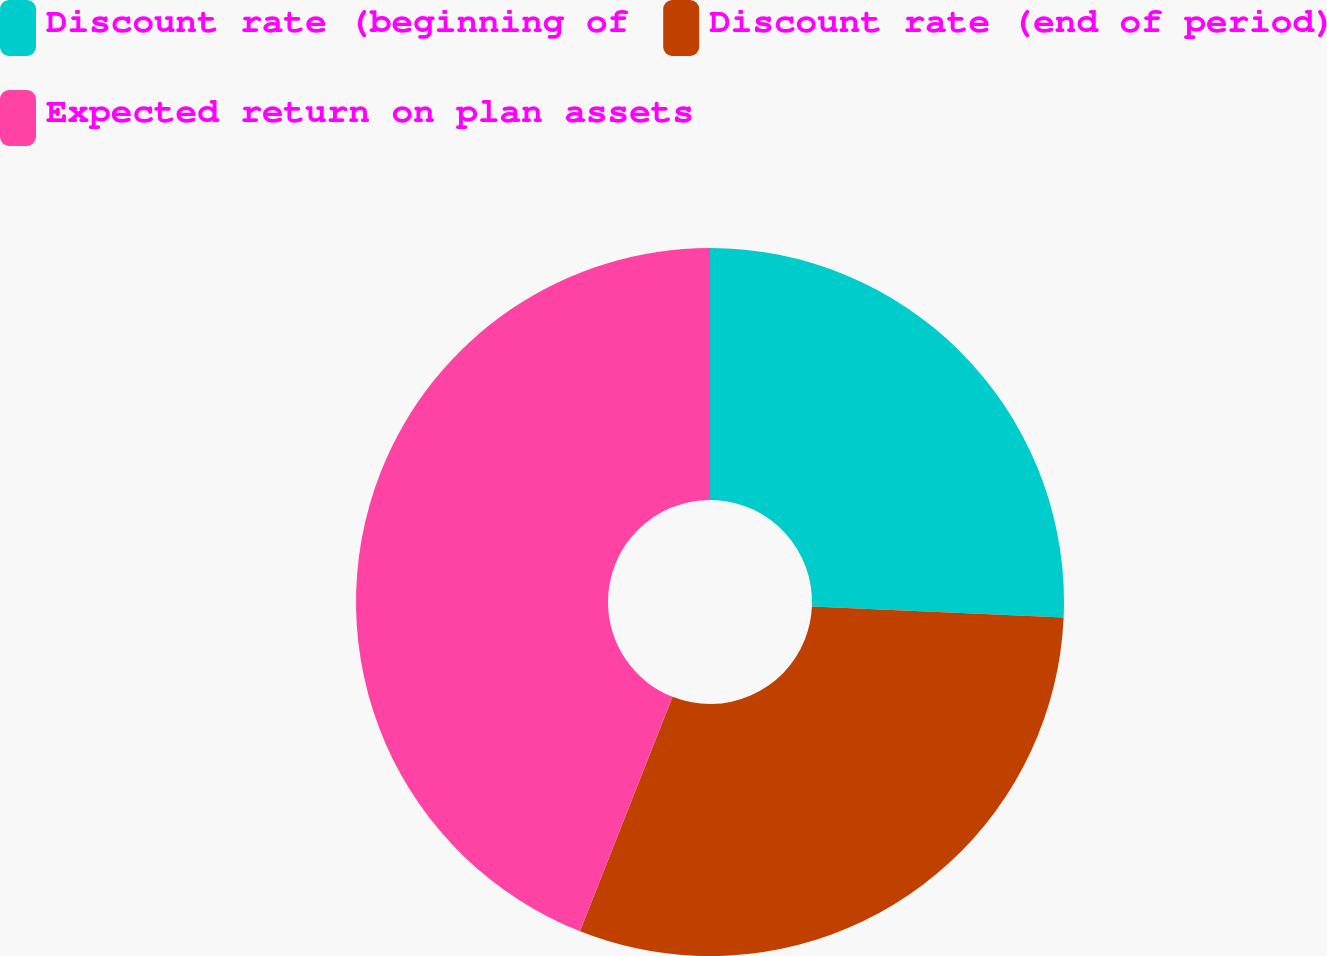Convert chart to OTSL. <chart><loc_0><loc_0><loc_500><loc_500><pie_chart><fcel>Discount rate (beginning of<fcel>Discount rate (end of period)<fcel>Expected return on plan assets<nl><fcel>25.7%<fcel>30.28%<fcel>44.01%<nl></chart> 